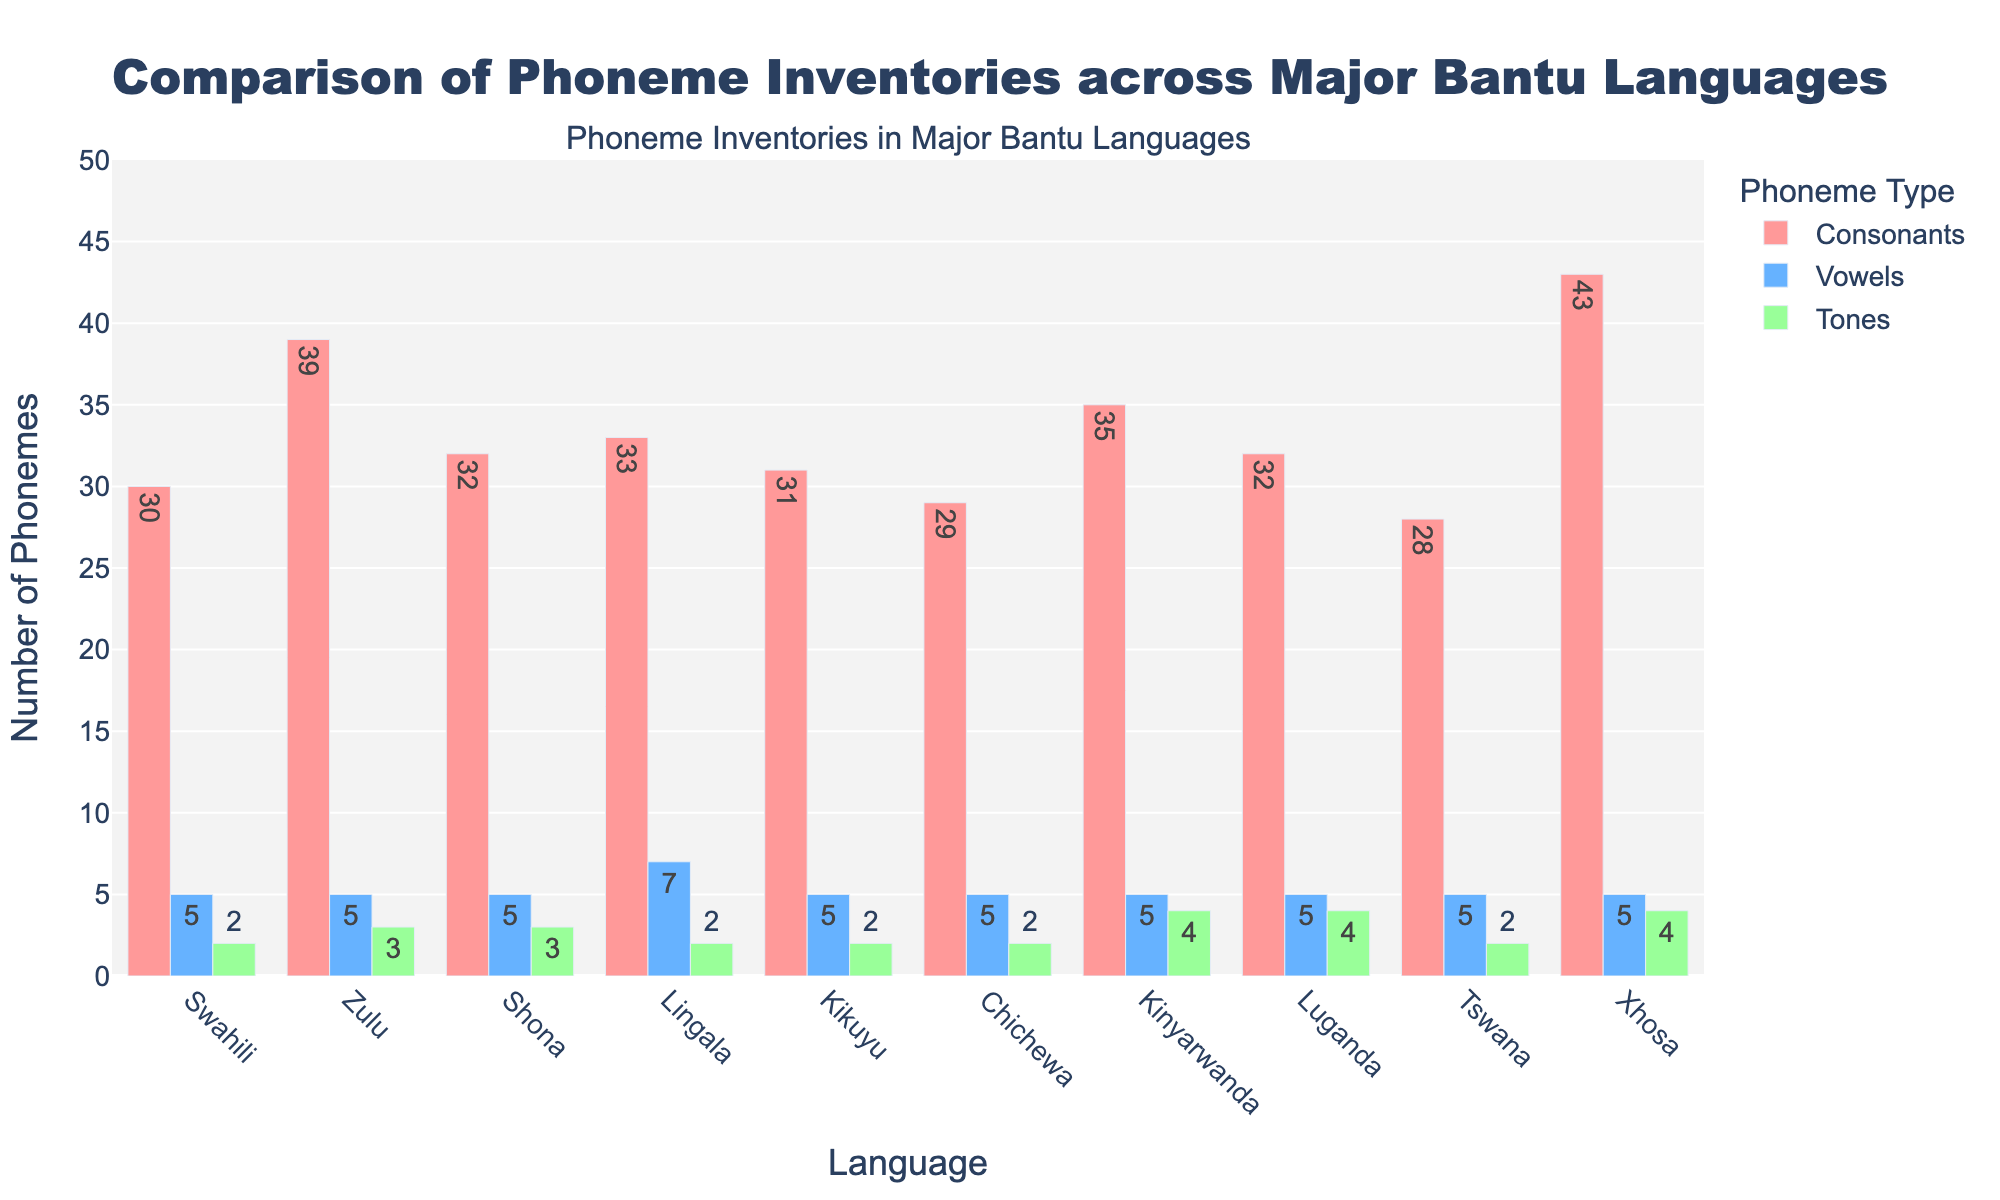Which language has the highest number of consonants? To find the language with the highest number of consonants, look at the height of the bars in the "Consonants" category and identify the highest one. Xhosa has the highest bar.
Answer: Xhosa Which two languages have the same number of tones? To find this, check for bars with the same height in the "Tones" category. Both Swahili and Kikuyu have bars of equal height in the "Tones" category with a value of 2.
Answer: Swahili, Kikuyu What's the total number of vowels across all languages? Sum the heights of all the bars in the "Vowels" category: 5 (Swahili) + 5 (Zulu) + 5 (Shona) + 7 (Lingala) + 5 (Kikuyu) + 5 (Chichewa) + 5 (Kinyarwanda) + 5 (Luganda) + 5 (Tswana) + 5 (Xhosa) = 52.
Answer: 52 Which language has the second highest total number of phonemes? First, identify the language with the highest total number of phonemes. Xhosa has the highest with 52. The second highest will be Kinyarwanda with 44 total phonemes.
Answer: Kinyarwanda Which language has more tones, Kinyarwanda or Luganda? Compare the heights of the bars in the "Tones" category for Kinyarwanda (4) and Luganda (4). Both languages have the same number of tones.
Answer: They have equal tones What's the average number of consonants in the languages? Sum the number of consonants for all languages and divide by the number of languages: (30 + 39 + 32 + 33 + 31 + 29 + 35 + 32 + 28 + 43) / 10 = 33.2.
Answer: 33.2 Which language has the fewest consonants? Identify the lowest bar in the "Consonants" category. Tswana has the fewest consonants with a value of 28.
Answer: Tswana How many languages have more than 3 tones? Count the bars in the "Tones" category that have a value greater than 3. Kinyarwanda, Luganda, and Xhosa have more than 3 tones.
Answer: 3 Which has more consonants, Swahili or Kikuyu, and by how many? Compare the bars in the "Consonants" category for Swahili (30) and Kikuyu (31). Kikuyu has 1 more consonant than Swahili.
Answer: Kikuyu, by 1 What is the average number of tones in Zulu, Shona, and Lingala? Sum the number of tones for Zulu (3), Shona (3), and Lingala (2), then divide by 3: (3 + 3 + 2) / 3 = 2.67.
Answer: 2.67 